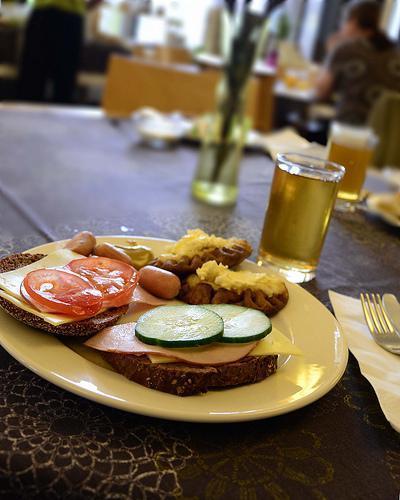How many cucumber slices are there?
Give a very brief answer. 2. How many people are there?
Give a very brief answer. 2. 